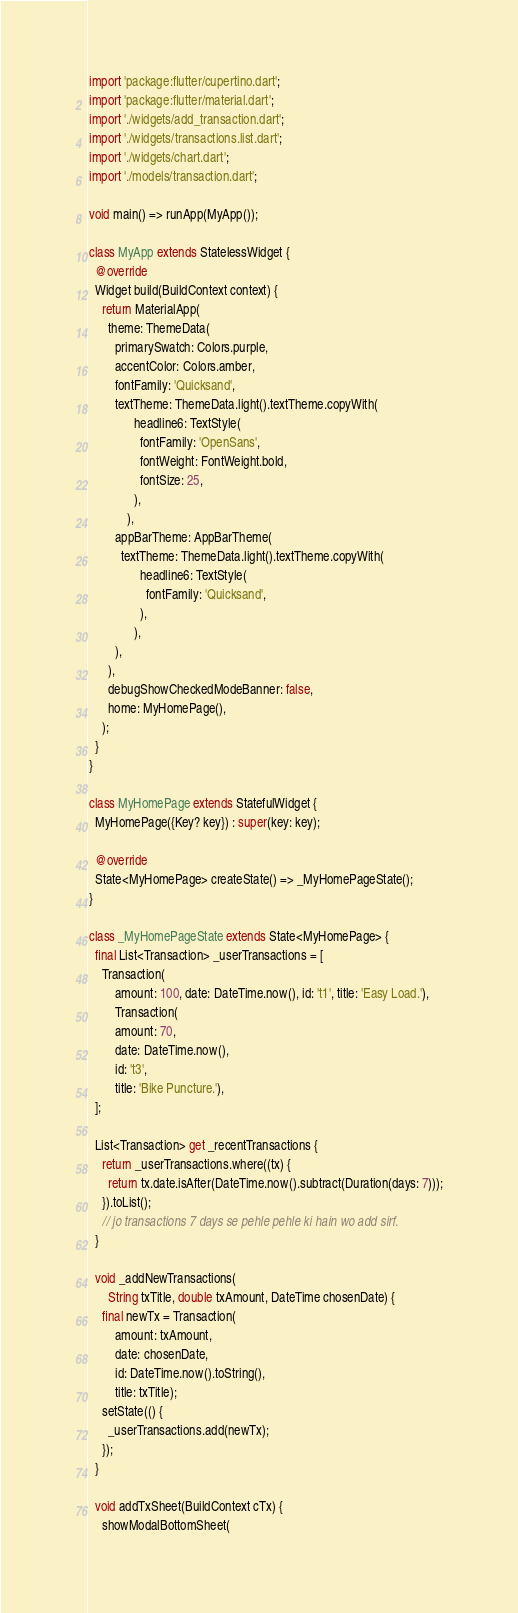<code> <loc_0><loc_0><loc_500><loc_500><_Dart_>import 'package:flutter/cupertino.dart';
import 'package:flutter/material.dart';
import './widgets/add_transaction.dart';
import './widgets/transactions.list.dart';
import './widgets/chart.dart';
import './models/transaction.dart';

void main() => runApp(MyApp());

class MyApp extends StatelessWidget {
  @override
  Widget build(BuildContext context) {
    return MaterialApp(
      theme: ThemeData(
        primarySwatch: Colors.purple,
        accentColor: Colors.amber,
        fontFamily: 'Quicksand',
        textTheme: ThemeData.light().textTheme.copyWith(
              headline6: TextStyle(
                fontFamily: 'OpenSans',
                fontWeight: FontWeight.bold,
                fontSize: 25,
              ),
            ),
        appBarTheme: AppBarTheme(
          textTheme: ThemeData.light().textTheme.copyWith(
                headline6: TextStyle(
                  fontFamily: 'Quicksand',
                ),
              ),
        ),
      ),
      debugShowCheckedModeBanner: false,
      home: MyHomePage(),
    );
  }
}

class MyHomePage extends StatefulWidget {
  MyHomePage({Key? key}) : super(key: key);

  @override
  State<MyHomePage> createState() => _MyHomePageState();
}

class _MyHomePageState extends State<MyHomePage> {
  final List<Transaction> _userTransactions = [
    Transaction(
        amount: 100, date: DateTime.now(), id: 't1', title: 'Easy Load.'),
        Transaction(
        amount: 70,
        date: DateTime.now(),
        id: 't3',
        title: 'Bike Puncture.'),
  ];

  List<Transaction> get _recentTransactions {
    return _userTransactions.where((tx) {
      return tx.date.isAfter(DateTime.now().subtract(Duration(days: 7)));
    }).toList();
    // jo transactions 7 days se pehle pehle ki hain wo add sirf.
  }

  void _addNewTransactions(
      String txTitle, double txAmount, DateTime chosenDate) {
    final newTx = Transaction(
        amount: txAmount,
        date: chosenDate,
        id: DateTime.now().toString(),
        title: txTitle);
    setState(() {
      _userTransactions.add(newTx);
    });
  }

  void addTxSheet(BuildContext cTx) {
    showModalBottomSheet(</code> 